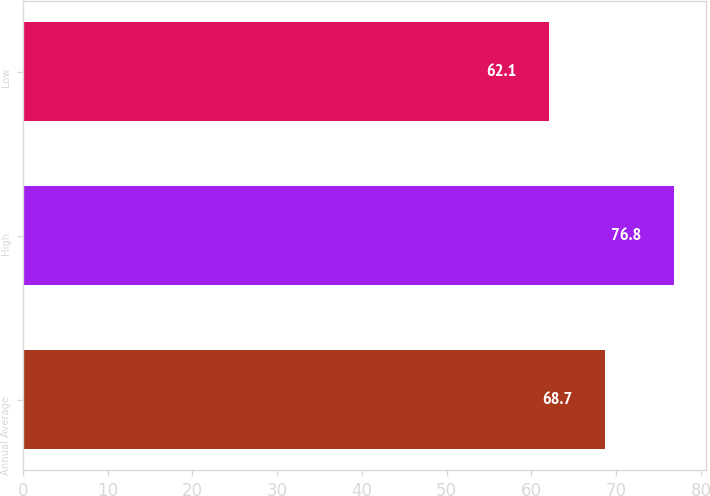Convert chart to OTSL. <chart><loc_0><loc_0><loc_500><loc_500><bar_chart><fcel>Annual Average<fcel>High<fcel>Low<nl><fcel>68.7<fcel>76.8<fcel>62.1<nl></chart> 